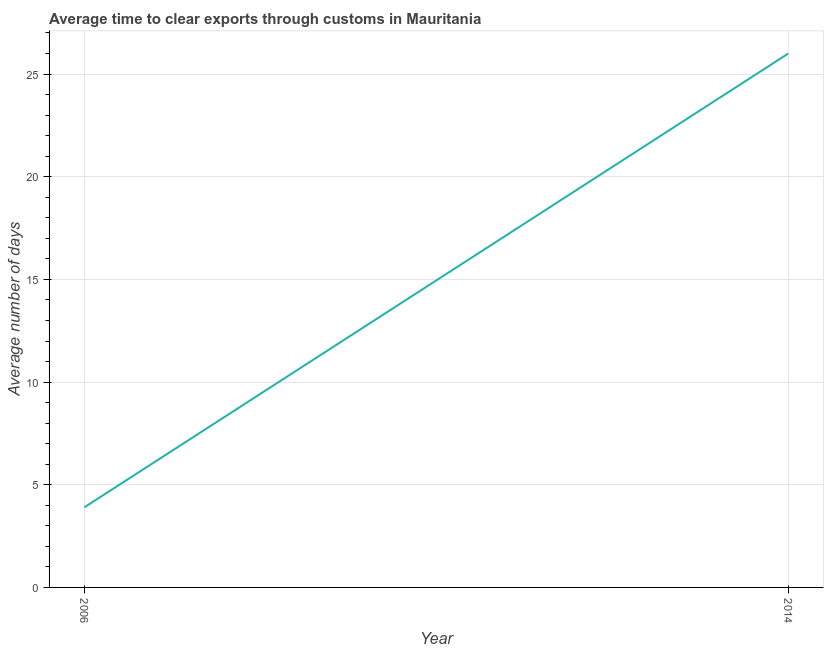Across all years, what is the maximum time to clear exports through customs?
Offer a very short reply. 26. Across all years, what is the minimum time to clear exports through customs?
Provide a short and direct response. 3.9. What is the sum of the time to clear exports through customs?
Make the answer very short. 29.9. What is the difference between the time to clear exports through customs in 2006 and 2014?
Your answer should be very brief. -22.1. What is the average time to clear exports through customs per year?
Your response must be concise. 14.95. What is the median time to clear exports through customs?
Your answer should be very brief. 14.95. What is the ratio of the time to clear exports through customs in 2006 to that in 2014?
Offer a very short reply. 0.15. Does the time to clear exports through customs monotonically increase over the years?
Your response must be concise. Yes. Are the values on the major ticks of Y-axis written in scientific E-notation?
Your answer should be compact. No. Does the graph contain any zero values?
Offer a terse response. No. Does the graph contain grids?
Your response must be concise. Yes. What is the title of the graph?
Provide a succinct answer. Average time to clear exports through customs in Mauritania. What is the label or title of the Y-axis?
Provide a short and direct response. Average number of days. What is the Average number of days in 2006?
Give a very brief answer. 3.9. What is the Average number of days of 2014?
Ensure brevity in your answer.  26. What is the difference between the Average number of days in 2006 and 2014?
Keep it short and to the point. -22.1. What is the ratio of the Average number of days in 2006 to that in 2014?
Provide a short and direct response. 0.15. 